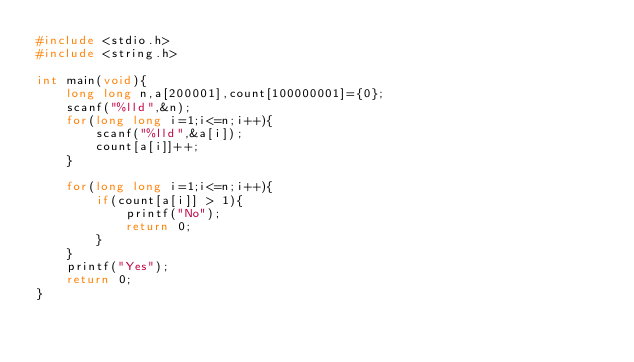<code> <loc_0><loc_0><loc_500><loc_500><_C_>#include <stdio.h>
#include <string.h>
 
int main(void){
    long long n,a[200001],count[100000001]={0};
    scanf("%lld",&n);
    for(long long i=1;i<=n;i++){
        scanf("%lld",&a[i]);
        count[a[i]]++;
    }
    
    for(long long i=1;i<=n;i++){
        if(count[a[i]] > 1){
            printf("No");
            return 0;
        }
    }
    printf("Yes");
    return 0;
}</code> 